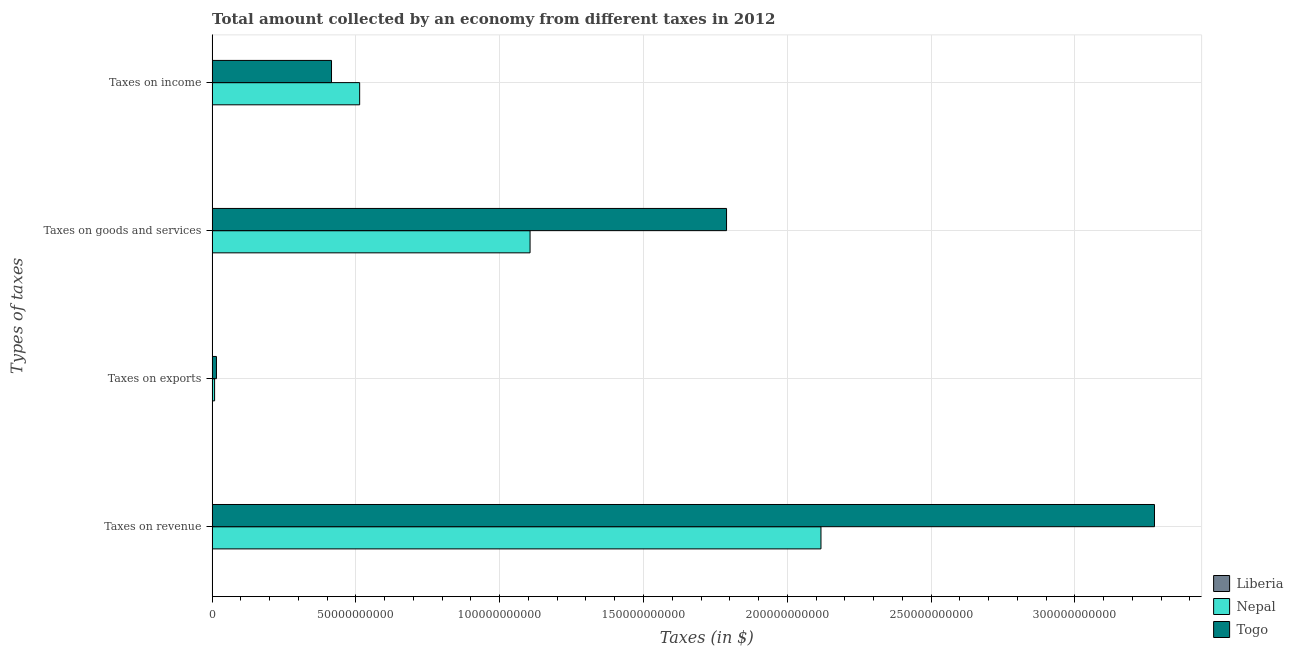Are the number of bars on each tick of the Y-axis equal?
Offer a very short reply. Yes. How many bars are there on the 3rd tick from the bottom?
Your answer should be very brief. 3. What is the label of the 1st group of bars from the top?
Ensure brevity in your answer.  Taxes on income. What is the amount collected as tax on exports in Nepal?
Your response must be concise. 8.62e+08. Across all countries, what is the maximum amount collected as tax on revenue?
Your answer should be very brief. 3.28e+11. Across all countries, what is the minimum amount collected as tax on exports?
Provide a short and direct response. 5.15e+04. In which country was the amount collected as tax on revenue maximum?
Provide a short and direct response. Togo. In which country was the amount collected as tax on revenue minimum?
Provide a short and direct response. Liberia. What is the total amount collected as tax on goods in the graph?
Provide a succinct answer. 2.89e+11. What is the difference between the amount collected as tax on income in Liberia and that in Nepal?
Offer a terse response. -5.13e+1. What is the difference between the amount collected as tax on revenue in Nepal and the amount collected as tax on exports in Liberia?
Provide a succinct answer. 2.12e+11. What is the average amount collected as tax on goods per country?
Keep it short and to the point. 9.65e+1. What is the difference between the amount collected as tax on income and amount collected as tax on revenue in Nepal?
Give a very brief answer. -1.60e+11. In how many countries, is the amount collected as tax on goods greater than 200000000000 $?
Provide a succinct answer. 0. What is the ratio of the amount collected as tax on income in Nepal to that in Togo?
Make the answer very short. 1.24. What is the difference between the highest and the second highest amount collected as tax on exports?
Your response must be concise. 6.44e+08. What is the difference between the highest and the lowest amount collected as tax on revenue?
Offer a very short reply. 3.28e+11. Is the sum of the amount collected as tax on exports in Liberia and Togo greater than the maximum amount collected as tax on goods across all countries?
Keep it short and to the point. No. What does the 3rd bar from the top in Taxes on income represents?
Keep it short and to the point. Liberia. What does the 2nd bar from the bottom in Taxes on revenue represents?
Your answer should be compact. Nepal. Is it the case that in every country, the sum of the amount collected as tax on revenue and amount collected as tax on exports is greater than the amount collected as tax on goods?
Ensure brevity in your answer.  Yes. How many countries are there in the graph?
Your response must be concise. 3. What is the difference between two consecutive major ticks on the X-axis?
Provide a short and direct response. 5.00e+1. Are the values on the major ticks of X-axis written in scientific E-notation?
Keep it short and to the point. No. Does the graph contain grids?
Make the answer very short. Yes. Where does the legend appear in the graph?
Your answer should be compact. Bottom right. How are the legend labels stacked?
Offer a very short reply. Vertical. What is the title of the graph?
Offer a very short reply. Total amount collected by an economy from different taxes in 2012. Does "Maldives" appear as one of the legend labels in the graph?
Provide a short and direct response. No. What is the label or title of the X-axis?
Your answer should be very brief. Taxes (in $). What is the label or title of the Y-axis?
Your answer should be very brief. Types of taxes. What is the Taxes (in $) in Liberia in Taxes on revenue?
Provide a succinct answer. 4.93e+06. What is the Taxes (in $) in Nepal in Taxes on revenue?
Your answer should be very brief. 2.12e+11. What is the Taxes (in $) in Togo in Taxes on revenue?
Provide a short and direct response. 3.28e+11. What is the Taxes (in $) in Liberia in Taxes on exports?
Ensure brevity in your answer.  5.15e+04. What is the Taxes (in $) in Nepal in Taxes on exports?
Keep it short and to the point. 8.62e+08. What is the Taxes (in $) of Togo in Taxes on exports?
Your response must be concise. 1.51e+09. What is the Taxes (in $) in Liberia in Taxes on goods and services?
Make the answer very short. 8.31e+05. What is the Taxes (in $) of Nepal in Taxes on goods and services?
Offer a terse response. 1.11e+11. What is the Taxes (in $) of Togo in Taxes on goods and services?
Give a very brief answer. 1.79e+11. What is the Taxes (in $) of Liberia in Taxes on income?
Provide a succinct answer. 1.73e+06. What is the Taxes (in $) of Nepal in Taxes on income?
Give a very brief answer. 5.13e+1. What is the Taxes (in $) of Togo in Taxes on income?
Make the answer very short. 4.15e+1. Across all Types of taxes, what is the maximum Taxes (in $) of Liberia?
Ensure brevity in your answer.  4.93e+06. Across all Types of taxes, what is the maximum Taxes (in $) of Nepal?
Offer a terse response. 2.12e+11. Across all Types of taxes, what is the maximum Taxes (in $) in Togo?
Ensure brevity in your answer.  3.28e+11. Across all Types of taxes, what is the minimum Taxes (in $) in Liberia?
Provide a succinct answer. 5.15e+04. Across all Types of taxes, what is the minimum Taxes (in $) in Nepal?
Ensure brevity in your answer.  8.62e+08. Across all Types of taxes, what is the minimum Taxes (in $) of Togo?
Provide a succinct answer. 1.51e+09. What is the total Taxes (in $) in Liberia in the graph?
Your answer should be very brief. 7.54e+06. What is the total Taxes (in $) in Nepal in the graph?
Provide a short and direct response. 3.74e+11. What is the total Taxes (in $) in Togo in the graph?
Your response must be concise. 5.50e+11. What is the difference between the Taxes (in $) in Liberia in Taxes on revenue and that in Taxes on exports?
Offer a terse response. 4.87e+06. What is the difference between the Taxes (in $) in Nepal in Taxes on revenue and that in Taxes on exports?
Provide a succinct answer. 2.11e+11. What is the difference between the Taxes (in $) of Togo in Taxes on revenue and that in Taxes on exports?
Provide a succinct answer. 3.26e+11. What is the difference between the Taxes (in $) of Liberia in Taxes on revenue and that in Taxes on goods and services?
Provide a succinct answer. 4.09e+06. What is the difference between the Taxes (in $) of Nepal in Taxes on revenue and that in Taxes on goods and services?
Provide a succinct answer. 1.01e+11. What is the difference between the Taxes (in $) of Togo in Taxes on revenue and that in Taxes on goods and services?
Your response must be concise. 1.49e+11. What is the difference between the Taxes (in $) of Liberia in Taxes on revenue and that in Taxes on income?
Provide a short and direct response. 3.19e+06. What is the difference between the Taxes (in $) in Nepal in Taxes on revenue and that in Taxes on income?
Your response must be concise. 1.60e+11. What is the difference between the Taxes (in $) in Togo in Taxes on revenue and that in Taxes on income?
Provide a short and direct response. 2.86e+11. What is the difference between the Taxes (in $) in Liberia in Taxes on exports and that in Taxes on goods and services?
Ensure brevity in your answer.  -7.80e+05. What is the difference between the Taxes (in $) of Nepal in Taxes on exports and that in Taxes on goods and services?
Your answer should be very brief. -1.10e+11. What is the difference between the Taxes (in $) of Togo in Taxes on exports and that in Taxes on goods and services?
Your response must be concise. -1.77e+11. What is the difference between the Taxes (in $) of Liberia in Taxes on exports and that in Taxes on income?
Provide a succinct answer. -1.68e+06. What is the difference between the Taxes (in $) of Nepal in Taxes on exports and that in Taxes on income?
Provide a succinct answer. -5.04e+1. What is the difference between the Taxes (in $) of Togo in Taxes on exports and that in Taxes on income?
Your answer should be very brief. -4.00e+1. What is the difference between the Taxes (in $) in Liberia in Taxes on goods and services and that in Taxes on income?
Provide a succinct answer. -9.00e+05. What is the difference between the Taxes (in $) in Nepal in Taxes on goods and services and that in Taxes on income?
Keep it short and to the point. 5.93e+1. What is the difference between the Taxes (in $) of Togo in Taxes on goods and services and that in Taxes on income?
Ensure brevity in your answer.  1.37e+11. What is the difference between the Taxes (in $) in Liberia in Taxes on revenue and the Taxes (in $) in Nepal in Taxes on exports?
Offer a very short reply. -8.57e+08. What is the difference between the Taxes (in $) of Liberia in Taxes on revenue and the Taxes (in $) of Togo in Taxes on exports?
Your answer should be very brief. -1.50e+09. What is the difference between the Taxes (in $) in Nepal in Taxes on revenue and the Taxes (in $) in Togo in Taxes on exports?
Offer a very short reply. 2.10e+11. What is the difference between the Taxes (in $) of Liberia in Taxes on revenue and the Taxes (in $) of Nepal in Taxes on goods and services?
Your answer should be compact. -1.11e+11. What is the difference between the Taxes (in $) in Liberia in Taxes on revenue and the Taxes (in $) in Togo in Taxes on goods and services?
Keep it short and to the point. -1.79e+11. What is the difference between the Taxes (in $) in Nepal in Taxes on revenue and the Taxes (in $) in Togo in Taxes on goods and services?
Provide a succinct answer. 3.28e+1. What is the difference between the Taxes (in $) in Liberia in Taxes on revenue and the Taxes (in $) in Nepal in Taxes on income?
Provide a succinct answer. -5.13e+1. What is the difference between the Taxes (in $) in Liberia in Taxes on revenue and the Taxes (in $) in Togo in Taxes on income?
Your response must be concise. -4.15e+1. What is the difference between the Taxes (in $) of Nepal in Taxes on revenue and the Taxes (in $) of Togo in Taxes on income?
Give a very brief answer. 1.70e+11. What is the difference between the Taxes (in $) in Liberia in Taxes on exports and the Taxes (in $) in Nepal in Taxes on goods and services?
Provide a short and direct response. -1.11e+11. What is the difference between the Taxes (in $) of Liberia in Taxes on exports and the Taxes (in $) of Togo in Taxes on goods and services?
Make the answer very short. -1.79e+11. What is the difference between the Taxes (in $) in Nepal in Taxes on exports and the Taxes (in $) in Togo in Taxes on goods and services?
Your response must be concise. -1.78e+11. What is the difference between the Taxes (in $) of Liberia in Taxes on exports and the Taxes (in $) of Nepal in Taxes on income?
Make the answer very short. -5.13e+1. What is the difference between the Taxes (in $) of Liberia in Taxes on exports and the Taxes (in $) of Togo in Taxes on income?
Your response must be concise. -4.15e+1. What is the difference between the Taxes (in $) in Nepal in Taxes on exports and the Taxes (in $) in Togo in Taxes on income?
Your answer should be very brief. -4.07e+1. What is the difference between the Taxes (in $) in Liberia in Taxes on goods and services and the Taxes (in $) in Nepal in Taxes on income?
Offer a very short reply. -5.13e+1. What is the difference between the Taxes (in $) of Liberia in Taxes on goods and services and the Taxes (in $) of Togo in Taxes on income?
Provide a succinct answer. -4.15e+1. What is the difference between the Taxes (in $) of Nepal in Taxes on goods and services and the Taxes (in $) of Togo in Taxes on income?
Provide a succinct answer. 6.90e+1. What is the average Taxes (in $) in Liberia per Types of taxes?
Your answer should be compact. 1.88e+06. What is the average Taxes (in $) of Nepal per Types of taxes?
Keep it short and to the point. 9.36e+1. What is the average Taxes (in $) of Togo per Types of taxes?
Provide a short and direct response. 1.37e+11. What is the difference between the Taxes (in $) in Liberia and Taxes (in $) in Nepal in Taxes on revenue?
Give a very brief answer. -2.12e+11. What is the difference between the Taxes (in $) of Liberia and Taxes (in $) of Togo in Taxes on revenue?
Provide a short and direct response. -3.28e+11. What is the difference between the Taxes (in $) in Nepal and Taxes (in $) in Togo in Taxes on revenue?
Offer a terse response. -1.16e+11. What is the difference between the Taxes (in $) in Liberia and Taxes (in $) in Nepal in Taxes on exports?
Give a very brief answer. -8.62e+08. What is the difference between the Taxes (in $) of Liberia and Taxes (in $) of Togo in Taxes on exports?
Your answer should be compact. -1.51e+09. What is the difference between the Taxes (in $) of Nepal and Taxes (in $) of Togo in Taxes on exports?
Give a very brief answer. -6.44e+08. What is the difference between the Taxes (in $) in Liberia and Taxes (in $) in Nepal in Taxes on goods and services?
Offer a very short reply. -1.11e+11. What is the difference between the Taxes (in $) of Liberia and Taxes (in $) of Togo in Taxes on goods and services?
Ensure brevity in your answer.  -1.79e+11. What is the difference between the Taxes (in $) in Nepal and Taxes (in $) in Togo in Taxes on goods and services?
Your answer should be compact. -6.83e+1. What is the difference between the Taxes (in $) in Liberia and Taxes (in $) in Nepal in Taxes on income?
Provide a succinct answer. -5.13e+1. What is the difference between the Taxes (in $) of Liberia and Taxes (in $) of Togo in Taxes on income?
Ensure brevity in your answer.  -4.15e+1. What is the difference between the Taxes (in $) in Nepal and Taxes (in $) in Togo in Taxes on income?
Provide a short and direct response. 9.79e+09. What is the ratio of the Taxes (in $) in Liberia in Taxes on revenue to that in Taxes on exports?
Offer a terse response. 95.57. What is the ratio of the Taxes (in $) of Nepal in Taxes on revenue to that in Taxes on exports?
Keep it short and to the point. 245.74. What is the ratio of the Taxes (in $) of Togo in Taxes on revenue to that in Taxes on exports?
Make the answer very short. 217.67. What is the ratio of the Taxes (in $) in Liberia in Taxes on revenue to that in Taxes on goods and services?
Your answer should be compact. 5.93. What is the ratio of the Taxes (in $) of Nepal in Taxes on revenue to that in Taxes on goods and services?
Your response must be concise. 1.92. What is the ratio of the Taxes (in $) in Togo in Taxes on revenue to that in Taxes on goods and services?
Your response must be concise. 1.83. What is the ratio of the Taxes (in $) of Liberia in Taxes on revenue to that in Taxes on income?
Keep it short and to the point. 2.85. What is the ratio of the Taxes (in $) of Nepal in Taxes on revenue to that in Taxes on income?
Your answer should be very brief. 4.13. What is the ratio of the Taxes (in $) of Togo in Taxes on revenue to that in Taxes on income?
Provide a short and direct response. 7.89. What is the ratio of the Taxes (in $) of Liberia in Taxes on exports to that in Taxes on goods and services?
Your response must be concise. 0.06. What is the ratio of the Taxes (in $) in Nepal in Taxes on exports to that in Taxes on goods and services?
Provide a succinct answer. 0.01. What is the ratio of the Taxes (in $) in Togo in Taxes on exports to that in Taxes on goods and services?
Your answer should be compact. 0.01. What is the ratio of the Taxes (in $) of Liberia in Taxes on exports to that in Taxes on income?
Offer a very short reply. 0.03. What is the ratio of the Taxes (in $) of Nepal in Taxes on exports to that in Taxes on income?
Give a very brief answer. 0.02. What is the ratio of the Taxes (in $) of Togo in Taxes on exports to that in Taxes on income?
Keep it short and to the point. 0.04. What is the ratio of the Taxes (in $) of Liberia in Taxes on goods and services to that in Taxes on income?
Offer a very short reply. 0.48. What is the ratio of the Taxes (in $) in Nepal in Taxes on goods and services to that in Taxes on income?
Provide a succinct answer. 2.16. What is the ratio of the Taxes (in $) of Togo in Taxes on goods and services to that in Taxes on income?
Ensure brevity in your answer.  4.31. What is the difference between the highest and the second highest Taxes (in $) in Liberia?
Provide a short and direct response. 3.19e+06. What is the difference between the highest and the second highest Taxes (in $) in Nepal?
Make the answer very short. 1.01e+11. What is the difference between the highest and the second highest Taxes (in $) of Togo?
Offer a terse response. 1.49e+11. What is the difference between the highest and the lowest Taxes (in $) of Liberia?
Your response must be concise. 4.87e+06. What is the difference between the highest and the lowest Taxes (in $) in Nepal?
Provide a succinct answer. 2.11e+11. What is the difference between the highest and the lowest Taxes (in $) of Togo?
Provide a short and direct response. 3.26e+11. 